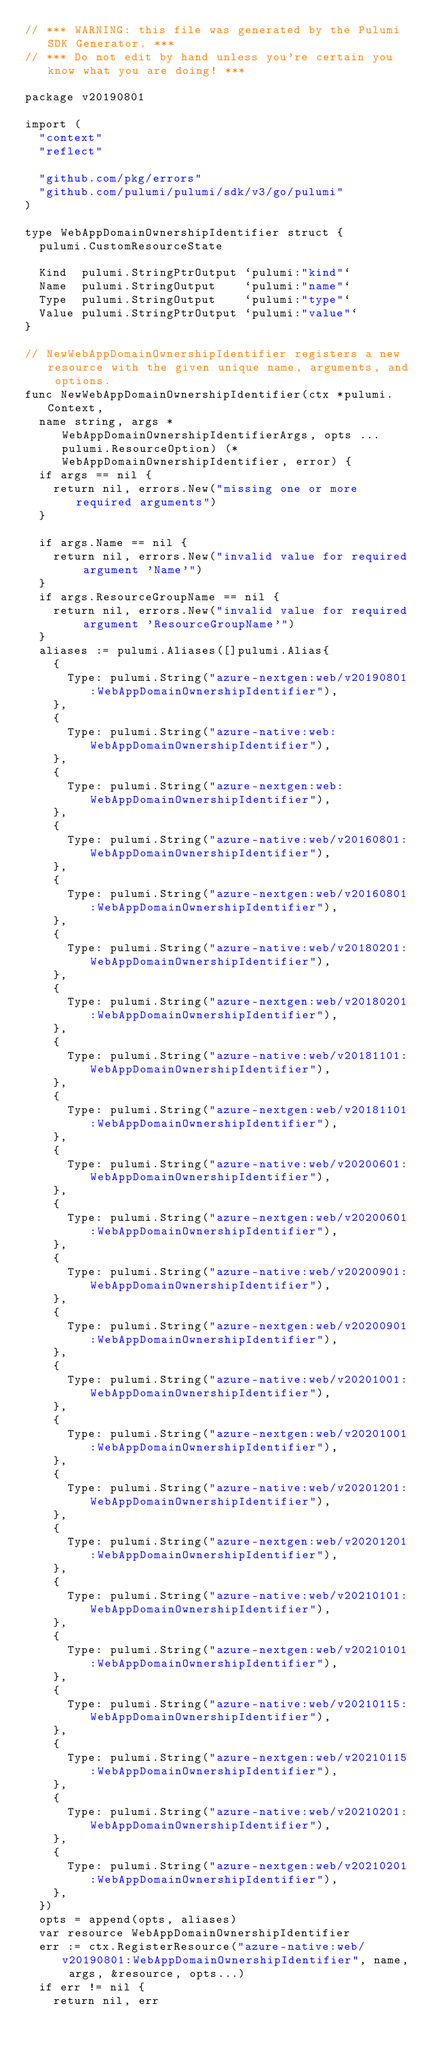Convert code to text. <code><loc_0><loc_0><loc_500><loc_500><_Go_>// *** WARNING: this file was generated by the Pulumi SDK Generator. ***
// *** Do not edit by hand unless you're certain you know what you are doing! ***

package v20190801

import (
	"context"
	"reflect"

	"github.com/pkg/errors"
	"github.com/pulumi/pulumi/sdk/v3/go/pulumi"
)

type WebAppDomainOwnershipIdentifier struct {
	pulumi.CustomResourceState

	Kind  pulumi.StringPtrOutput `pulumi:"kind"`
	Name  pulumi.StringOutput    `pulumi:"name"`
	Type  pulumi.StringOutput    `pulumi:"type"`
	Value pulumi.StringPtrOutput `pulumi:"value"`
}

// NewWebAppDomainOwnershipIdentifier registers a new resource with the given unique name, arguments, and options.
func NewWebAppDomainOwnershipIdentifier(ctx *pulumi.Context,
	name string, args *WebAppDomainOwnershipIdentifierArgs, opts ...pulumi.ResourceOption) (*WebAppDomainOwnershipIdentifier, error) {
	if args == nil {
		return nil, errors.New("missing one or more required arguments")
	}

	if args.Name == nil {
		return nil, errors.New("invalid value for required argument 'Name'")
	}
	if args.ResourceGroupName == nil {
		return nil, errors.New("invalid value for required argument 'ResourceGroupName'")
	}
	aliases := pulumi.Aliases([]pulumi.Alias{
		{
			Type: pulumi.String("azure-nextgen:web/v20190801:WebAppDomainOwnershipIdentifier"),
		},
		{
			Type: pulumi.String("azure-native:web:WebAppDomainOwnershipIdentifier"),
		},
		{
			Type: pulumi.String("azure-nextgen:web:WebAppDomainOwnershipIdentifier"),
		},
		{
			Type: pulumi.String("azure-native:web/v20160801:WebAppDomainOwnershipIdentifier"),
		},
		{
			Type: pulumi.String("azure-nextgen:web/v20160801:WebAppDomainOwnershipIdentifier"),
		},
		{
			Type: pulumi.String("azure-native:web/v20180201:WebAppDomainOwnershipIdentifier"),
		},
		{
			Type: pulumi.String("azure-nextgen:web/v20180201:WebAppDomainOwnershipIdentifier"),
		},
		{
			Type: pulumi.String("azure-native:web/v20181101:WebAppDomainOwnershipIdentifier"),
		},
		{
			Type: pulumi.String("azure-nextgen:web/v20181101:WebAppDomainOwnershipIdentifier"),
		},
		{
			Type: pulumi.String("azure-native:web/v20200601:WebAppDomainOwnershipIdentifier"),
		},
		{
			Type: pulumi.String("azure-nextgen:web/v20200601:WebAppDomainOwnershipIdentifier"),
		},
		{
			Type: pulumi.String("azure-native:web/v20200901:WebAppDomainOwnershipIdentifier"),
		},
		{
			Type: pulumi.String("azure-nextgen:web/v20200901:WebAppDomainOwnershipIdentifier"),
		},
		{
			Type: pulumi.String("azure-native:web/v20201001:WebAppDomainOwnershipIdentifier"),
		},
		{
			Type: pulumi.String("azure-nextgen:web/v20201001:WebAppDomainOwnershipIdentifier"),
		},
		{
			Type: pulumi.String("azure-native:web/v20201201:WebAppDomainOwnershipIdentifier"),
		},
		{
			Type: pulumi.String("azure-nextgen:web/v20201201:WebAppDomainOwnershipIdentifier"),
		},
		{
			Type: pulumi.String("azure-native:web/v20210101:WebAppDomainOwnershipIdentifier"),
		},
		{
			Type: pulumi.String("azure-nextgen:web/v20210101:WebAppDomainOwnershipIdentifier"),
		},
		{
			Type: pulumi.String("azure-native:web/v20210115:WebAppDomainOwnershipIdentifier"),
		},
		{
			Type: pulumi.String("azure-nextgen:web/v20210115:WebAppDomainOwnershipIdentifier"),
		},
		{
			Type: pulumi.String("azure-native:web/v20210201:WebAppDomainOwnershipIdentifier"),
		},
		{
			Type: pulumi.String("azure-nextgen:web/v20210201:WebAppDomainOwnershipIdentifier"),
		},
	})
	opts = append(opts, aliases)
	var resource WebAppDomainOwnershipIdentifier
	err := ctx.RegisterResource("azure-native:web/v20190801:WebAppDomainOwnershipIdentifier", name, args, &resource, opts...)
	if err != nil {
		return nil, err</code> 